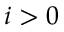<formula> <loc_0><loc_0><loc_500><loc_500>i > 0</formula> 